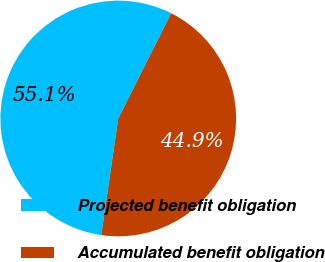<chart> <loc_0><loc_0><loc_500><loc_500><pie_chart><fcel>Projected benefit obligation<fcel>Accumulated benefit obligation<nl><fcel>55.11%<fcel>44.89%<nl></chart> 